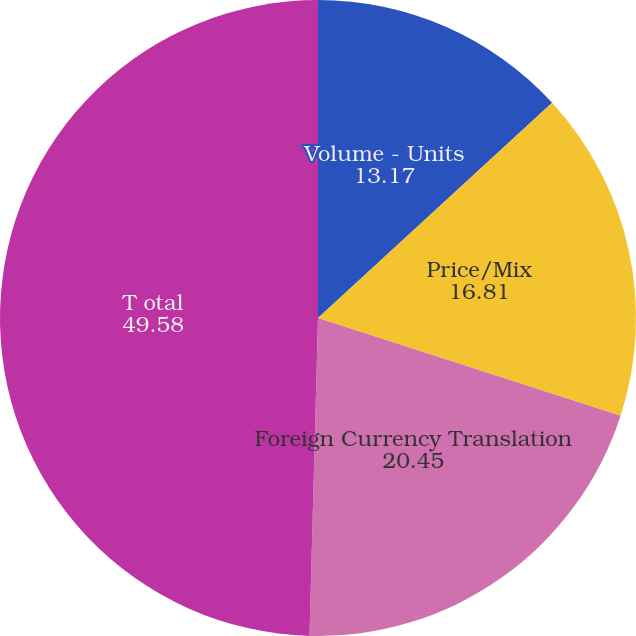Convert chart to OTSL. <chart><loc_0><loc_0><loc_500><loc_500><pie_chart><fcel>Volume - Units<fcel>Price/Mix<fcel>Foreign Currency Translation<fcel>T otal<nl><fcel>13.17%<fcel>16.81%<fcel>20.45%<fcel>49.58%<nl></chart> 